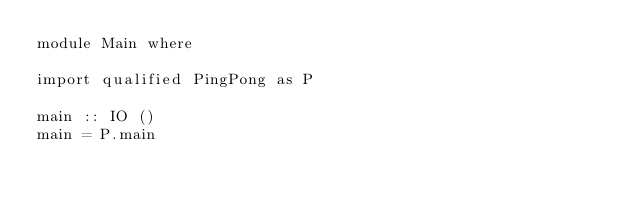Convert code to text. <code><loc_0><loc_0><loc_500><loc_500><_Haskell_>module Main where

import qualified PingPong as P

main :: IO ()
main = P.main
</code> 